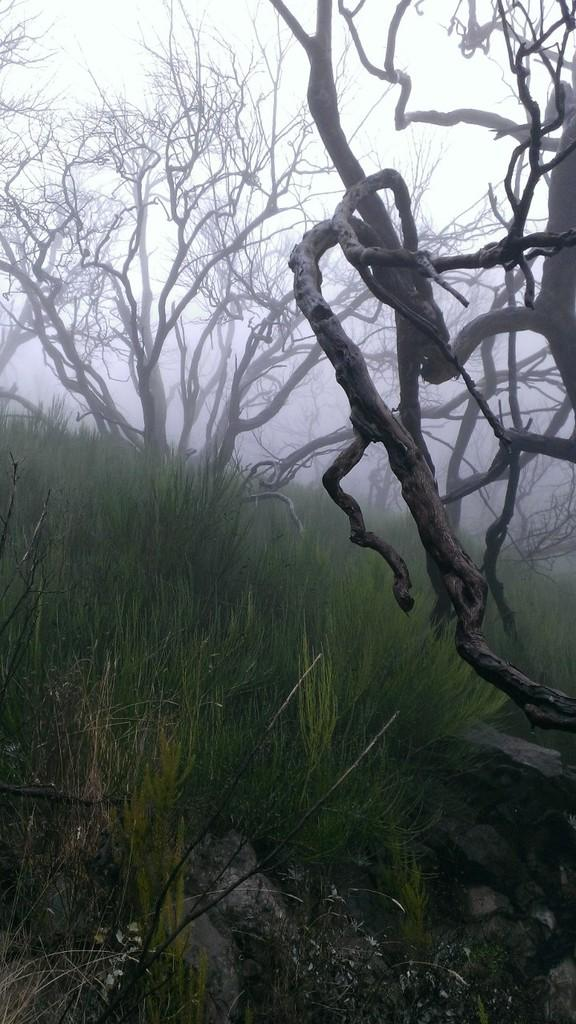What type of natural elements can be seen in the image? There are stones, grass, and trees visible in the image. What atmospheric condition is present in the image? There is fog in the image. What type of dolls can be seen playing with a feather in the image? There are no dolls or feathers present in the image; it features stones, grass, trees, and fog. 